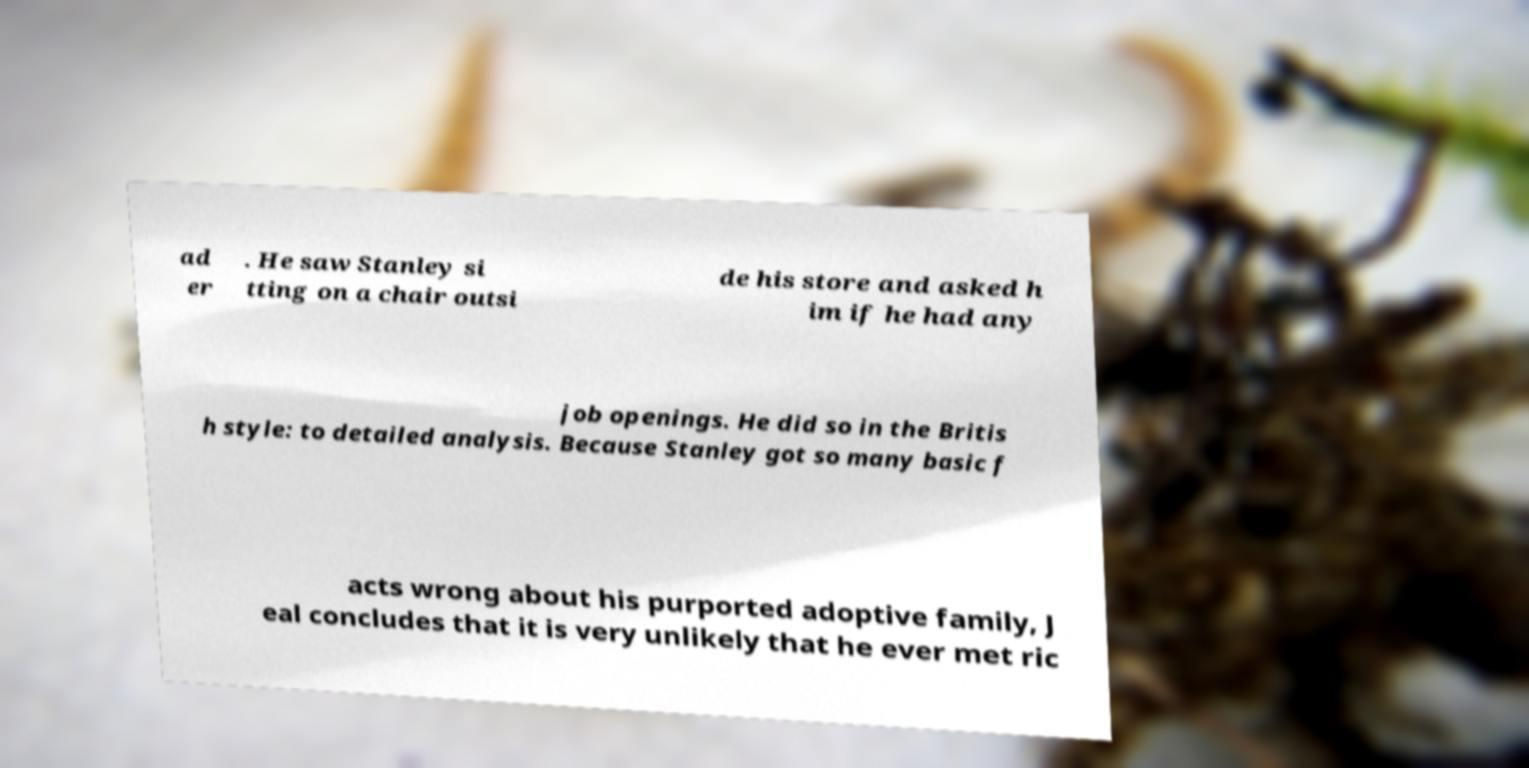Can you accurately transcribe the text from the provided image for me? ad er . He saw Stanley si tting on a chair outsi de his store and asked h im if he had any job openings. He did so in the Britis h style: to detailed analysis. Because Stanley got so many basic f acts wrong about his purported adoptive family, J eal concludes that it is very unlikely that he ever met ric 